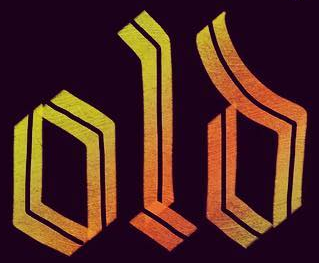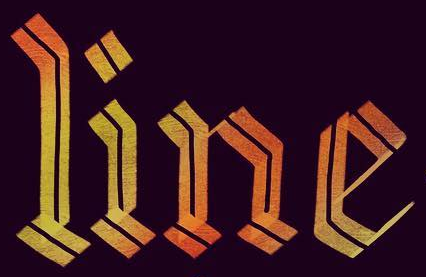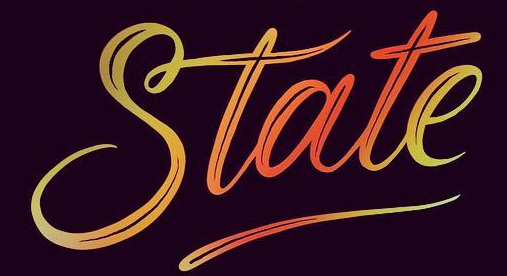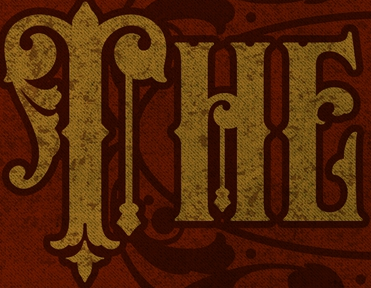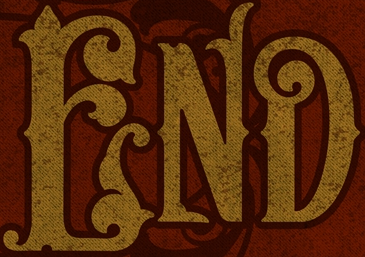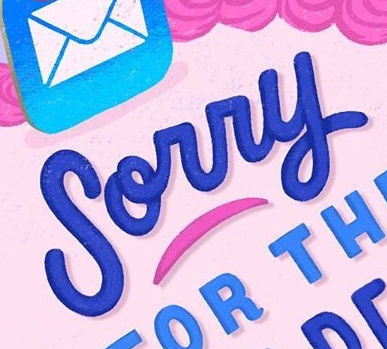Transcribe the words shown in these images in order, separated by a semicolon. old; line; State; THE; END; Sorry 